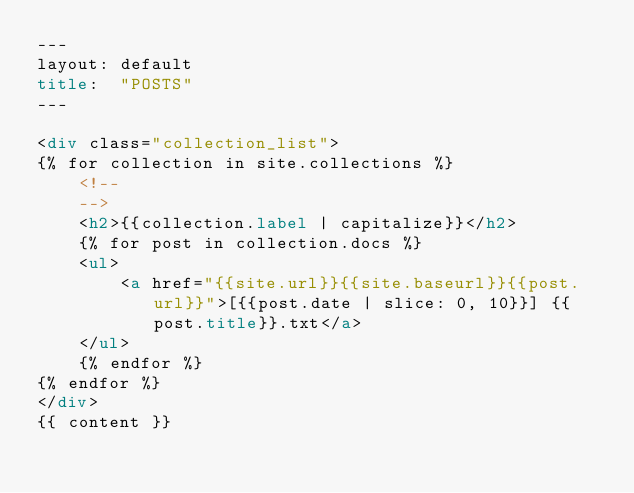<code> <loc_0><loc_0><loc_500><loc_500><_HTML_>---
layout: default
title:  "POSTS"
---

<div class="collection_list">
{% for collection in site.collections %}
    <!--
    -->
    <h2>{{collection.label | capitalize}}</h2>
    {% for post in collection.docs %}
    <ul>
        <a href="{{site.url}}{{site.baseurl}}{{post.url}}">[{{post.date | slice: 0, 10}}] {{post.title}}.txt</a>  
    </ul>
    {% endfor %}
{% endfor %}
</div>
{{ content }}

</code> 